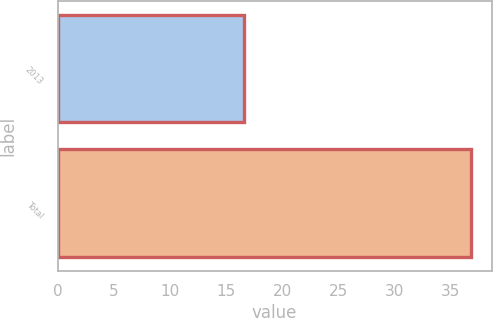Convert chart to OTSL. <chart><loc_0><loc_0><loc_500><loc_500><bar_chart><fcel>2013<fcel>Total<nl><fcel>16.6<fcel>36.8<nl></chart> 